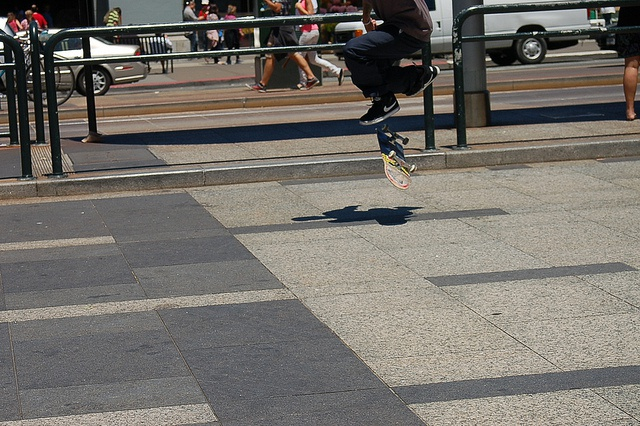Describe the objects in this image and their specific colors. I can see people in black, gray, and darkgray tones, truck in black, darkgray, gray, and lightgray tones, car in black, gray, white, and darkgray tones, people in black, maroon, and brown tones, and car in black, gray, darkgray, and white tones in this image. 